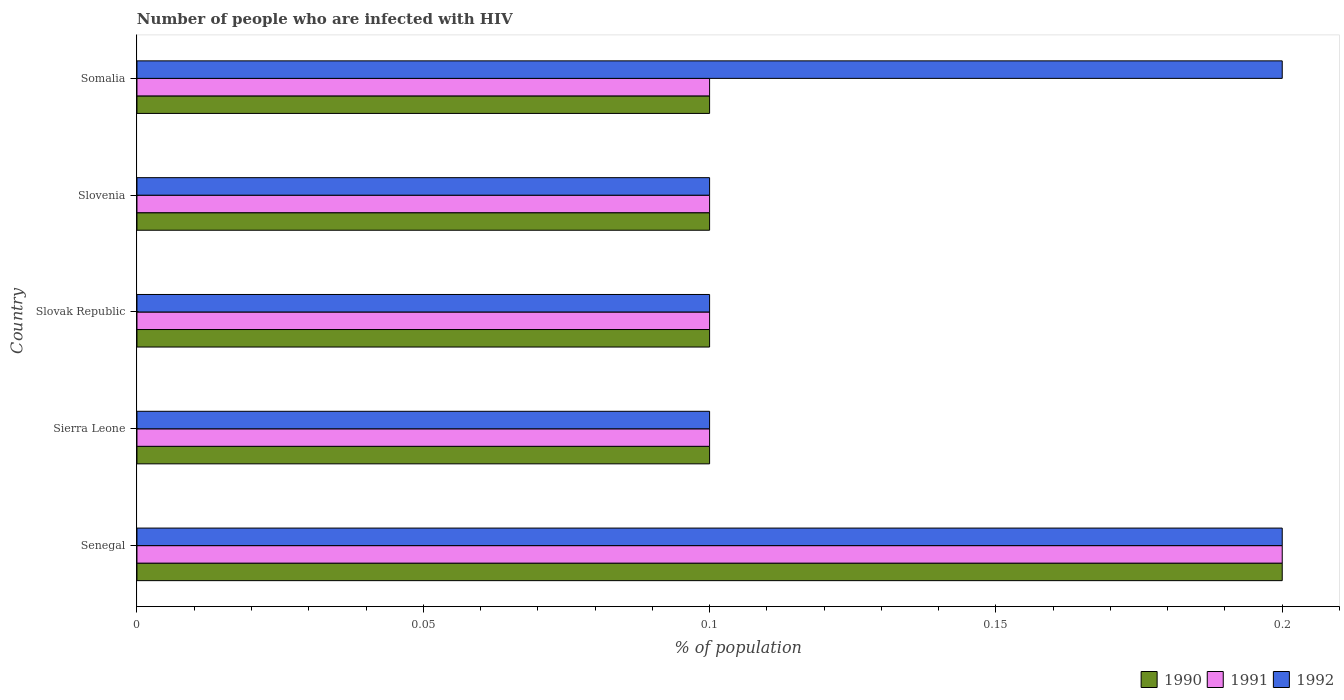How many different coloured bars are there?
Offer a very short reply. 3. How many groups of bars are there?
Keep it short and to the point. 5. Are the number of bars per tick equal to the number of legend labels?
Your answer should be very brief. Yes. Are the number of bars on each tick of the Y-axis equal?
Your response must be concise. Yes. What is the label of the 3rd group of bars from the top?
Your answer should be very brief. Slovak Republic. What is the percentage of HIV infected population in in 1990 in Slovenia?
Offer a very short reply. 0.1. Across all countries, what is the maximum percentage of HIV infected population in in 1991?
Ensure brevity in your answer.  0.2. In which country was the percentage of HIV infected population in in 1991 maximum?
Offer a very short reply. Senegal. In which country was the percentage of HIV infected population in in 1992 minimum?
Offer a very short reply. Sierra Leone. What is the total percentage of HIV infected population in in 1990 in the graph?
Ensure brevity in your answer.  0.6. What is the difference between the percentage of HIV infected population in in 1990 in Slovenia and that in Somalia?
Provide a succinct answer. 0. What is the average percentage of HIV infected population in in 1992 per country?
Your response must be concise. 0.14. In how many countries, is the percentage of HIV infected population in in 1991 greater than 0.05 %?
Offer a terse response. 5. What is the ratio of the percentage of HIV infected population in in 1990 in Senegal to that in Somalia?
Offer a terse response. 2. Is the sum of the percentage of HIV infected population in in 1990 in Slovak Republic and Slovenia greater than the maximum percentage of HIV infected population in in 1991 across all countries?
Provide a succinct answer. No. Is it the case that in every country, the sum of the percentage of HIV infected population in in 1990 and percentage of HIV infected population in in 1992 is greater than the percentage of HIV infected population in in 1991?
Your answer should be very brief. Yes. Are all the bars in the graph horizontal?
Give a very brief answer. Yes. Where does the legend appear in the graph?
Give a very brief answer. Bottom right. How many legend labels are there?
Make the answer very short. 3. What is the title of the graph?
Provide a short and direct response. Number of people who are infected with HIV. What is the label or title of the X-axis?
Provide a succinct answer. % of population. What is the label or title of the Y-axis?
Your response must be concise. Country. What is the % of population of 1990 in Senegal?
Offer a very short reply. 0.2. What is the % of population in 1992 in Senegal?
Offer a terse response. 0.2. What is the % of population in 1991 in Sierra Leone?
Ensure brevity in your answer.  0.1. What is the % of population in 1992 in Sierra Leone?
Ensure brevity in your answer.  0.1. What is the % of population of 1990 in Slovak Republic?
Keep it short and to the point. 0.1. What is the % of population in 1992 in Slovak Republic?
Offer a very short reply. 0.1. What is the % of population in 1990 in Slovenia?
Make the answer very short. 0.1. What is the % of population in 1991 in Somalia?
Provide a succinct answer. 0.1. What is the % of population of 1992 in Somalia?
Your answer should be very brief. 0.2. Across all countries, what is the maximum % of population of 1992?
Keep it short and to the point. 0.2. Across all countries, what is the minimum % of population in 1990?
Your answer should be very brief. 0.1. What is the total % of population of 1992 in the graph?
Provide a short and direct response. 0.7. What is the difference between the % of population of 1991 in Senegal and that in Sierra Leone?
Offer a terse response. 0.1. What is the difference between the % of population in 1992 in Senegal and that in Sierra Leone?
Give a very brief answer. 0.1. What is the difference between the % of population of 1990 in Senegal and that in Slovak Republic?
Your answer should be very brief. 0.1. What is the difference between the % of population in 1991 in Senegal and that in Slovak Republic?
Keep it short and to the point. 0.1. What is the difference between the % of population of 1990 in Senegal and that in Somalia?
Provide a short and direct response. 0.1. What is the difference between the % of population of 1991 in Senegal and that in Somalia?
Offer a terse response. 0.1. What is the difference between the % of population of 1992 in Senegal and that in Somalia?
Your answer should be compact. 0. What is the difference between the % of population in 1990 in Sierra Leone and that in Slovak Republic?
Ensure brevity in your answer.  0. What is the difference between the % of population in 1991 in Sierra Leone and that in Slovak Republic?
Your answer should be compact. 0. What is the difference between the % of population in 1992 in Sierra Leone and that in Slovak Republic?
Your answer should be compact. 0. What is the difference between the % of population in 1990 in Sierra Leone and that in Slovenia?
Make the answer very short. 0. What is the difference between the % of population of 1991 in Sierra Leone and that in Slovenia?
Your answer should be very brief. 0. What is the difference between the % of population in 1992 in Sierra Leone and that in Slovenia?
Make the answer very short. 0. What is the difference between the % of population in 1991 in Sierra Leone and that in Somalia?
Make the answer very short. 0. What is the difference between the % of population of 1992 in Sierra Leone and that in Somalia?
Make the answer very short. -0.1. What is the difference between the % of population of 1990 in Slovak Republic and that in Somalia?
Ensure brevity in your answer.  0. What is the difference between the % of population in 1990 in Senegal and the % of population in 1991 in Sierra Leone?
Provide a succinct answer. 0.1. What is the difference between the % of population of 1990 in Senegal and the % of population of 1991 in Slovak Republic?
Provide a succinct answer. 0.1. What is the difference between the % of population of 1990 in Senegal and the % of population of 1992 in Slovak Republic?
Offer a terse response. 0.1. What is the difference between the % of population of 1990 in Senegal and the % of population of 1991 in Slovenia?
Ensure brevity in your answer.  0.1. What is the difference between the % of population in 1991 in Senegal and the % of population in 1992 in Somalia?
Provide a succinct answer. 0. What is the difference between the % of population of 1990 in Sierra Leone and the % of population of 1991 in Slovak Republic?
Keep it short and to the point. 0. What is the difference between the % of population of 1990 in Sierra Leone and the % of population of 1992 in Slovak Republic?
Offer a terse response. 0. What is the difference between the % of population in 1990 in Sierra Leone and the % of population in 1992 in Slovenia?
Make the answer very short. 0. What is the difference between the % of population of 1991 in Sierra Leone and the % of population of 1992 in Slovenia?
Your response must be concise. 0. What is the difference between the % of population of 1990 in Sierra Leone and the % of population of 1991 in Somalia?
Provide a short and direct response. 0. What is the difference between the % of population in 1991 in Sierra Leone and the % of population in 1992 in Somalia?
Keep it short and to the point. -0.1. What is the difference between the % of population of 1990 in Slovak Republic and the % of population of 1991 in Slovenia?
Offer a terse response. 0. What is the difference between the % of population of 1990 in Slovak Republic and the % of population of 1991 in Somalia?
Offer a very short reply. 0. What is the difference between the % of population of 1990 in Slovak Republic and the % of population of 1992 in Somalia?
Keep it short and to the point. -0.1. What is the difference between the % of population of 1990 in Slovenia and the % of population of 1991 in Somalia?
Make the answer very short. 0. What is the difference between the % of population of 1991 in Slovenia and the % of population of 1992 in Somalia?
Provide a succinct answer. -0.1. What is the average % of population of 1990 per country?
Provide a short and direct response. 0.12. What is the average % of population of 1991 per country?
Make the answer very short. 0.12. What is the average % of population of 1992 per country?
Offer a terse response. 0.14. What is the difference between the % of population of 1990 and % of population of 1992 in Senegal?
Provide a succinct answer. 0. What is the difference between the % of population of 1990 and % of population of 1991 in Sierra Leone?
Your answer should be very brief. 0. What is the difference between the % of population in 1990 and % of population in 1992 in Sierra Leone?
Offer a terse response. 0. What is the difference between the % of population in 1991 and % of population in 1992 in Sierra Leone?
Your answer should be very brief. 0. What is the difference between the % of population in 1990 and % of population in 1991 in Slovak Republic?
Keep it short and to the point. 0. What is the difference between the % of population in 1990 and % of population in 1992 in Slovak Republic?
Offer a terse response. 0. What is the difference between the % of population of 1991 and % of population of 1992 in Slovak Republic?
Give a very brief answer. 0. What is the difference between the % of population of 1990 and % of population of 1991 in Slovenia?
Provide a short and direct response. 0. What is the difference between the % of population of 1990 and % of population of 1992 in Slovenia?
Make the answer very short. 0. What is the difference between the % of population of 1990 and % of population of 1991 in Somalia?
Make the answer very short. 0. What is the difference between the % of population in 1990 and % of population in 1992 in Somalia?
Offer a very short reply. -0.1. What is the difference between the % of population in 1991 and % of population in 1992 in Somalia?
Your answer should be very brief. -0.1. What is the ratio of the % of population of 1990 in Senegal to that in Sierra Leone?
Your answer should be compact. 2. What is the ratio of the % of population of 1991 in Senegal to that in Sierra Leone?
Offer a terse response. 2. What is the ratio of the % of population of 1990 in Senegal to that in Slovak Republic?
Give a very brief answer. 2. What is the ratio of the % of population of 1991 in Senegal to that in Slovak Republic?
Your answer should be very brief. 2. What is the ratio of the % of population of 1992 in Senegal to that in Slovak Republic?
Your answer should be compact. 2. What is the ratio of the % of population of 1990 in Senegal to that in Slovenia?
Offer a very short reply. 2. What is the ratio of the % of population in 1992 in Senegal to that in Slovenia?
Your response must be concise. 2. What is the ratio of the % of population of 1992 in Senegal to that in Somalia?
Give a very brief answer. 1. What is the ratio of the % of population in 1992 in Sierra Leone to that in Slovak Republic?
Your answer should be compact. 1. What is the ratio of the % of population in 1990 in Sierra Leone to that in Slovenia?
Your answer should be compact. 1. What is the ratio of the % of population of 1991 in Sierra Leone to that in Slovenia?
Ensure brevity in your answer.  1. What is the ratio of the % of population in 1992 in Sierra Leone to that in Slovenia?
Ensure brevity in your answer.  1. What is the ratio of the % of population in 1992 in Sierra Leone to that in Somalia?
Keep it short and to the point. 0.5. What is the ratio of the % of population in 1991 in Slovak Republic to that in Slovenia?
Offer a very short reply. 1. What is the ratio of the % of population in 1990 in Slovak Republic to that in Somalia?
Provide a succinct answer. 1. What is the ratio of the % of population of 1992 in Slovak Republic to that in Somalia?
Give a very brief answer. 0.5. What is the ratio of the % of population in 1990 in Slovenia to that in Somalia?
Make the answer very short. 1. What is the ratio of the % of population in 1991 in Slovenia to that in Somalia?
Your response must be concise. 1. What is the difference between the highest and the second highest % of population of 1991?
Your response must be concise. 0.1. What is the difference between the highest and the second highest % of population of 1992?
Your response must be concise. 0. What is the difference between the highest and the lowest % of population in 1992?
Give a very brief answer. 0.1. 